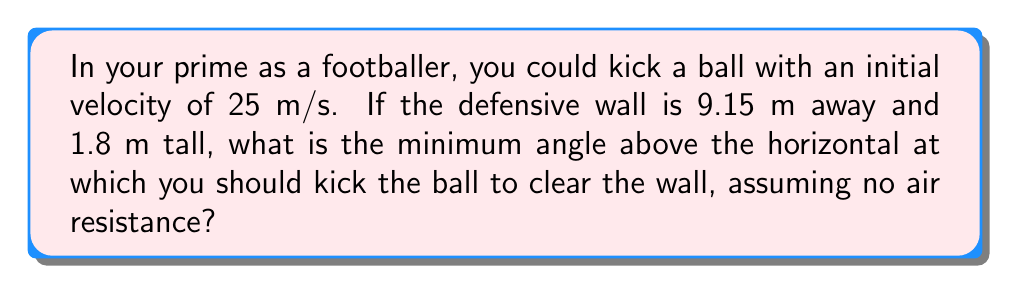Could you help me with this problem? Let's approach this step-by-step:

1) We can model the trajectory of the ball as a parabola described by the equation:

   $$y = x \tan \theta - \frac{gx^2}{2v_0^2 \cos^2 \theta}$$

   where $y$ is the height, $x$ is the horizontal distance, $\theta$ is the angle of launch, $g$ is the acceleration due to gravity (9.8 m/s²), and $v_0$ is the initial velocity.

2) We want to find the minimum angle $\theta$ such that when $x = 9.15$ m, $y \geq 1.8$ m.

3) Substituting these values into our equation:

   $$1.8 = 9.15 \tan \theta - \frac{9.8 \cdot 9.15^2}{2 \cdot 25^2 \cos^2 \theta}$$

4) Simplifying:

   $$1.8 = 9.15 \tan \theta - 0.165 \sec^2 \theta$$

5) This equation can be solved numerically. Using a calculator or computer algebra system, we find:

   $$\theta \approx 0.2097 \text{ radians}$$

6) Converting to degrees:

   $$\theta \approx 12.01°$$

[asy]
import geometry;

unitsize(1cm);

real theta = 0.2097;
real v0 = 25;
real g = 9.8;
real t = 9.15 / (v0*cos(theta));
real x(real t) { return v0*cos(theta)*t; }
real y(real t) { return v0*sin(theta)*t - 0.5*g*t^2; }

draw((0,0)--(10,0), arrow=Arrow);
draw((0,0)--(0,2), arrow=Arrow);

draw((0,0)--(9.15,1.8), dashed);
draw((9.15,0)--(9.15,1.8), dashed);

path trajectory = graph(x, y, 0, t);
draw(trajectory, blue);

label("9.15 m", (4.575,-0.2), S);
label("1.8 m", (9.35,0.9), E);
label("$\theta$", (0.5,0.2), NE);

dot((0,0));
dot((9.15,1.8));
[/asy]
Answer: $12.01°$ 